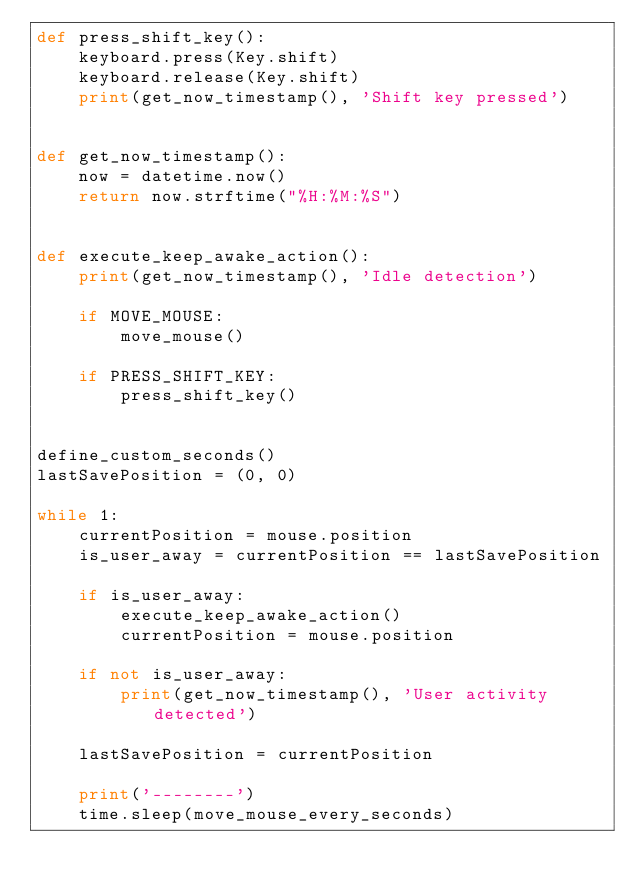<code> <loc_0><loc_0><loc_500><loc_500><_Python_>def press_shift_key():
    keyboard.press(Key.shift)
    keyboard.release(Key.shift)
    print(get_now_timestamp(), 'Shift key pressed')


def get_now_timestamp():
    now = datetime.now()
    return now.strftime("%H:%M:%S")


def execute_keep_awake_action():
    print(get_now_timestamp(), 'Idle detection')

    if MOVE_MOUSE:
        move_mouse()

    if PRESS_SHIFT_KEY:
        press_shift_key()


define_custom_seconds()
lastSavePosition = (0, 0)

while 1:
    currentPosition = mouse.position
    is_user_away = currentPosition == lastSavePosition

    if is_user_away:
        execute_keep_awake_action()
        currentPosition = mouse.position

    if not is_user_away:
        print(get_now_timestamp(), 'User activity detected')

    lastSavePosition = currentPosition

    print('--------')
    time.sleep(move_mouse_every_seconds)</code> 